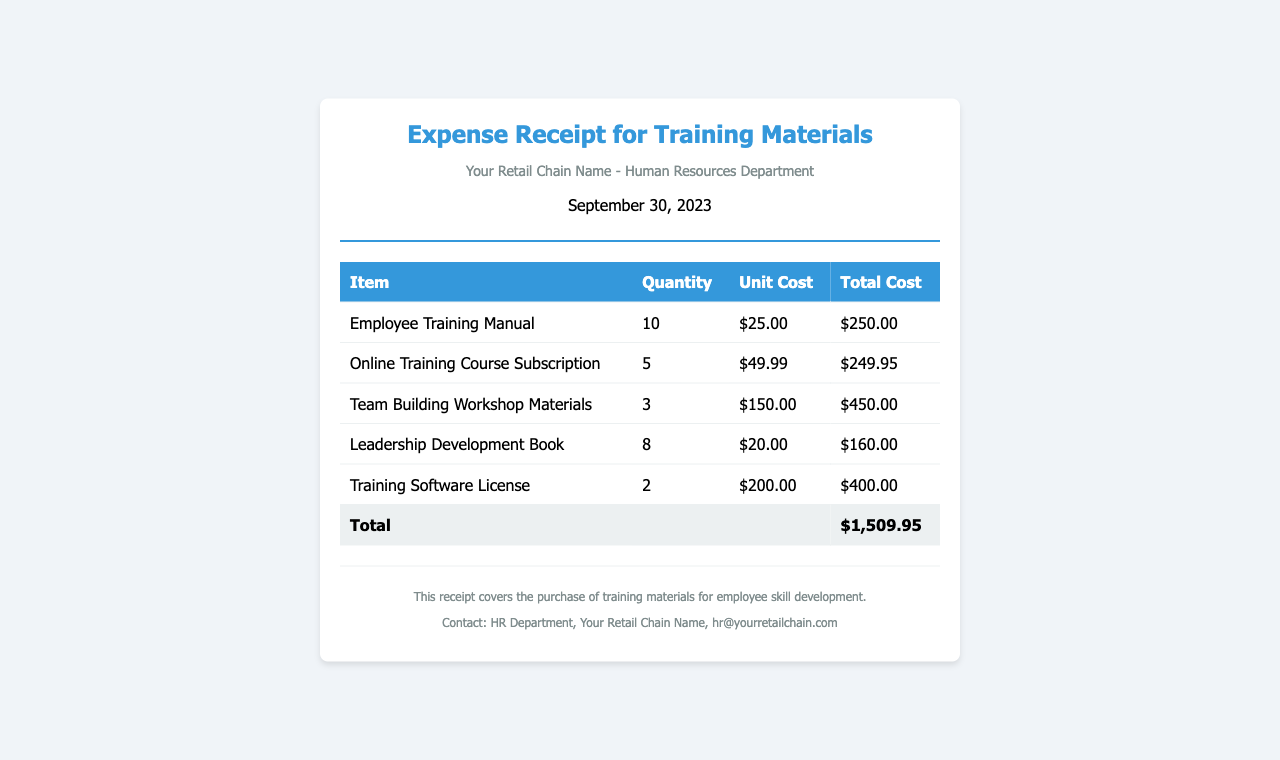What is the date of the receipt? The receipt is dated September 30, 2023.
Answer: September 30, 2023 How many Employee Training Manuals were purchased? The number of Employee Training Manuals purchased is specified in the document as 10.
Answer: 10 What is the total cost of the Leadership Development Books? The total cost for the Leadership Development Books is calculated as 8 books at $20.00 each, which is $160.00.
Answer: $160.00 What item had the highest total cost? The item with the highest total cost is the Team Building Workshop Materials, totaling $450.00.
Answer: Team Building Workshop Materials What is the total amount spent on all training materials? The total amount spent is listed at the end of the table as $1,509.95, which sums up all individual item costs.
Answer: $1,509.95 